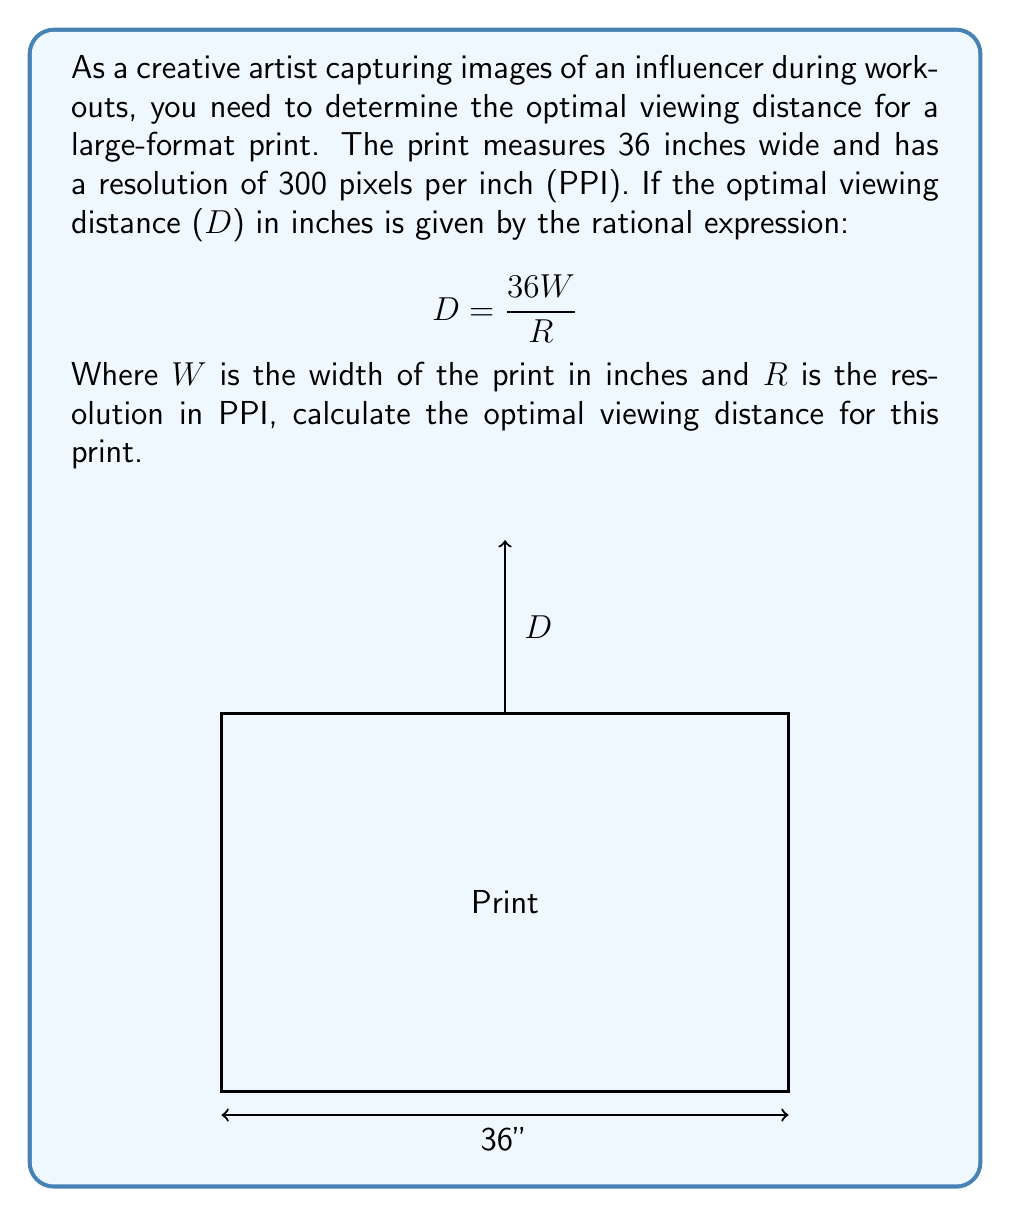Could you help me with this problem? Let's solve this problem step by step:

1) We are given the rational expression for optimal viewing distance:
   $$D = \frac{36W}{R}$$

2) We know the following:
   - W (width of the print) = 36 inches
   - R (resolution) = 300 PPI

3) Let's substitute these values into our equation:
   $$D = \frac{36 \cdot 36}{300}$$

4) Simplify the numerator:
   $$D = \frac{1296}{300}$$

5) Divide the numerator by the denominator:
   $$D = 4.32$$

6) Round to the nearest inch for practical use:
   $$D ≈ 4 \text{ inches}$$

Therefore, the optimal viewing distance for this print is approximately 4 inches.
Answer: $4 \text{ inches}$ 